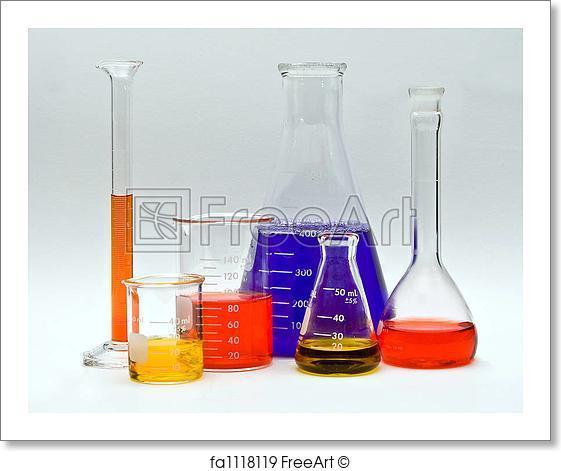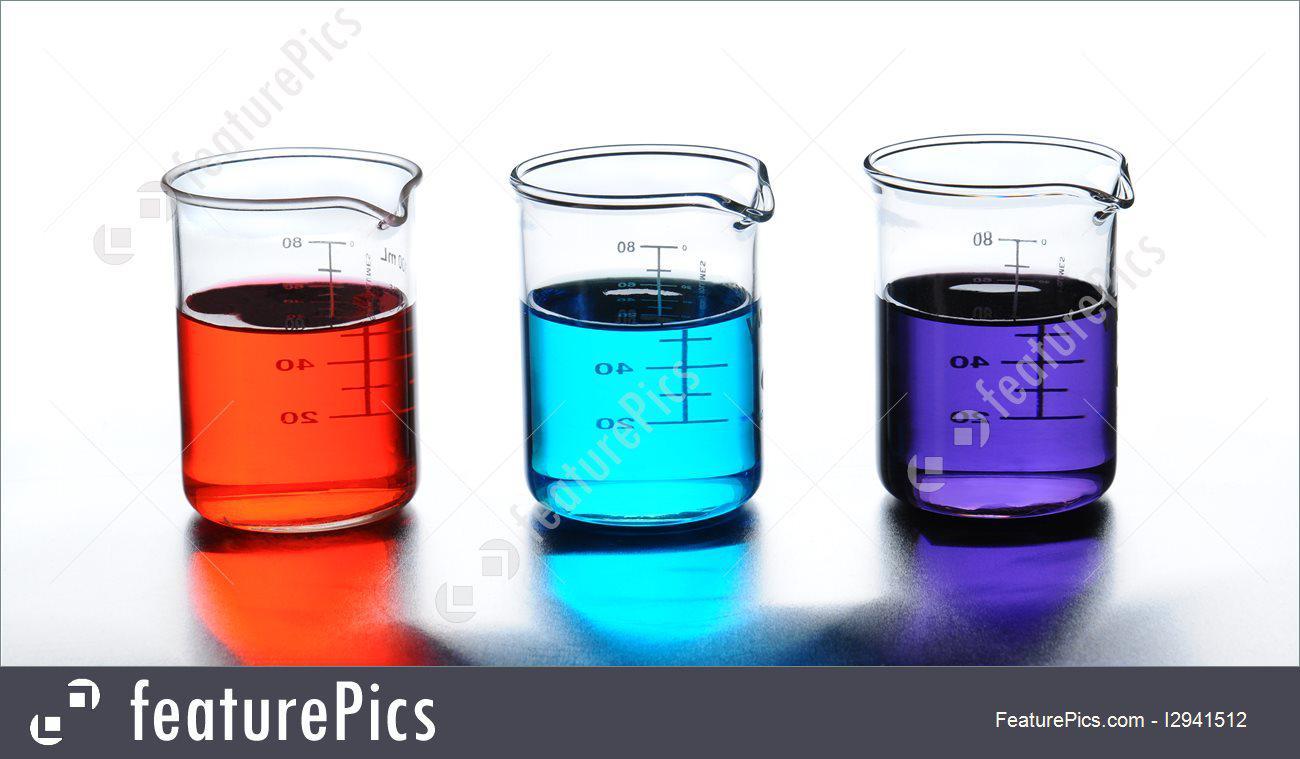The first image is the image on the left, the second image is the image on the right. For the images shown, is this caption "The image on the right has at least 4 beakers." true? Answer yes or no. No. The first image is the image on the left, the second image is the image on the right. For the images shown, is this caption "There are less than nine containers." true? Answer yes or no. No. 